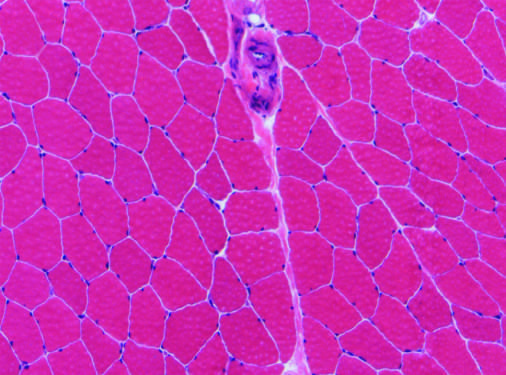what does a perimysial interfascicular septum contain?
Answer the question using a single word or phrase. A blood vessel 